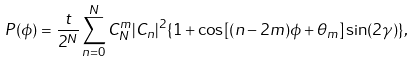Convert formula to latex. <formula><loc_0><loc_0><loc_500><loc_500>P ( \phi ) = \frac { t } { 2 ^ { N } } \sum _ { n = 0 } ^ { N } C ^ { m } _ { N } | C _ { n } | ^ { 2 } \{ 1 + \cos [ ( n - 2 m ) \phi + \theta _ { m } ] \sin ( 2 \gamma ) \} ,</formula> 